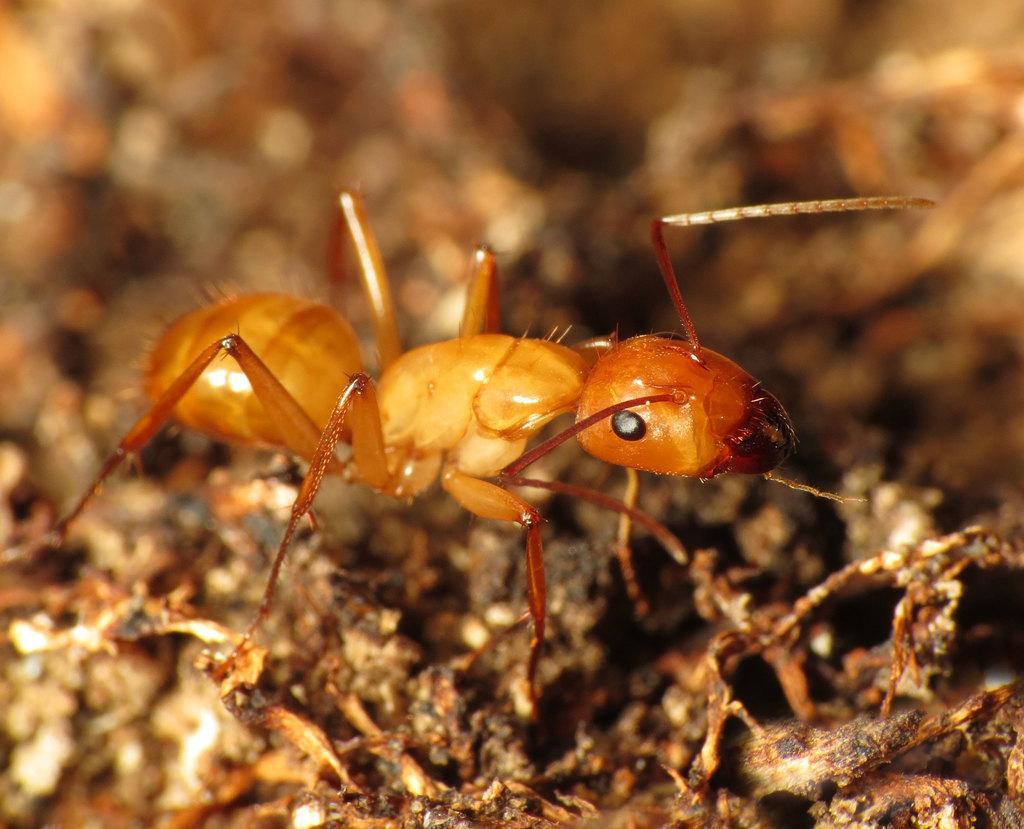Could you give a brief overview of what you see in this image? In the image we can see an ant pale brown in color. The background is blurred. 